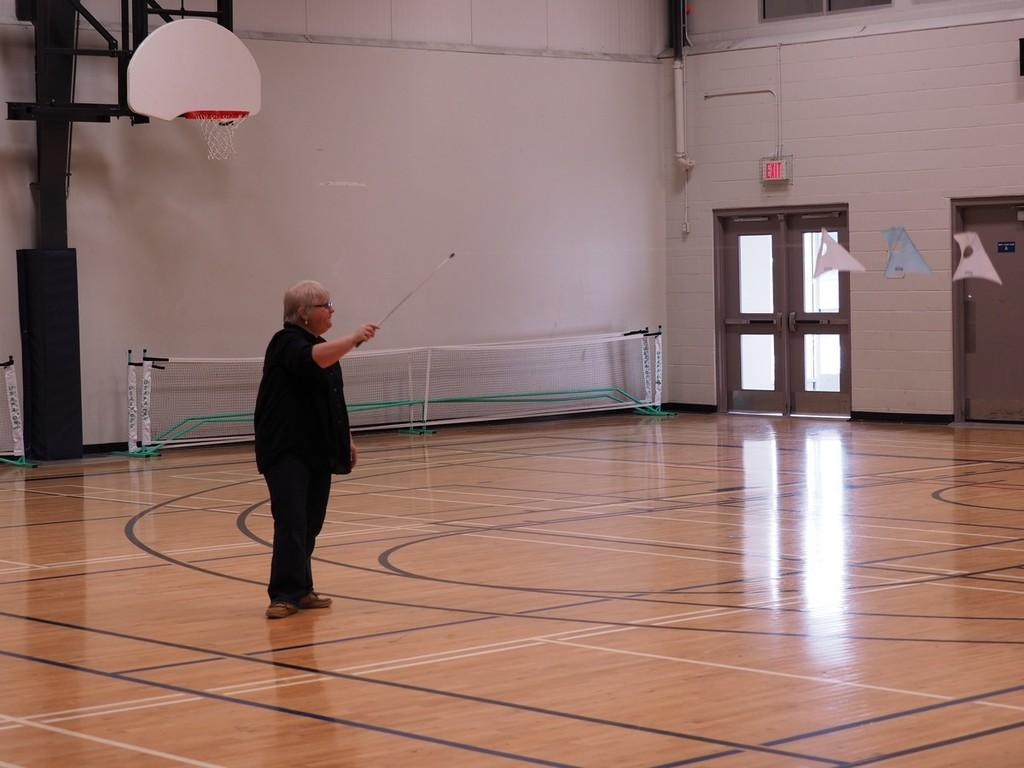What is the main subject of the image? There is a woman in the image. What is the woman holding in the image? The woman is holding a stick. Where is the woman standing in the image? The woman is standing on the floor. What can be seen in the background of the image? There are nets, a wall, doors, a basket, a stand, a sign board, pipes, and glass objects in the background of the image. What type of trucks can be seen in the image? There are no trucks present in the image. What shape is the rain taking in the image? There is no rain present in the image. 